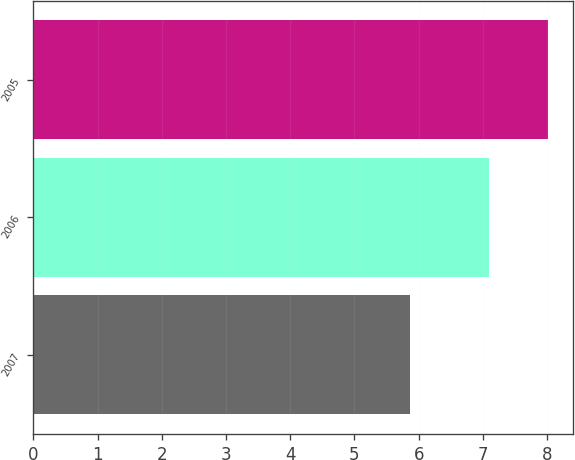<chart> <loc_0><loc_0><loc_500><loc_500><bar_chart><fcel>2007<fcel>2006<fcel>2005<nl><fcel>5.87<fcel>7.09<fcel>8.01<nl></chart> 